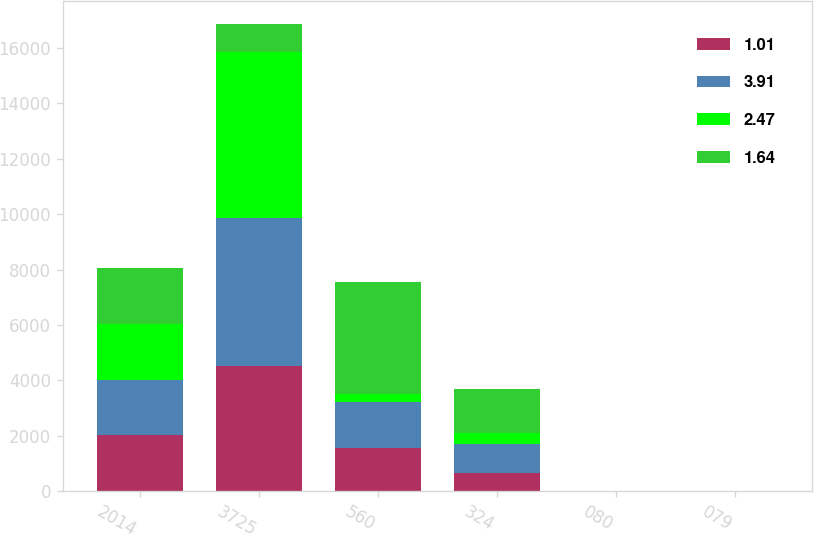Convert chart. <chart><loc_0><loc_0><loc_500><loc_500><stacked_bar_chart><ecel><fcel>2014<fcel>3725<fcel>560<fcel>324<fcel>080<fcel>079<nl><fcel>1.01<fcel>2014<fcel>4510<fcel>1554<fcel>675<fcel>1.65<fcel>1.64<nl><fcel>3.91<fcel>2014<fcel>5336<fcel>1654<fcel>1016<fcel>2.48<fcel>2.47<nl><fcel>2.47<fcel>2014<fcel>5995<fcel>291<fcel>408<fcel>1.01<fcel>1.01<nl><fcel>1.64<fcel>2014<fcel>1016<fcel>4059<fcel>1607<fcel>3.93<fcel>3.91<nl></chart> 